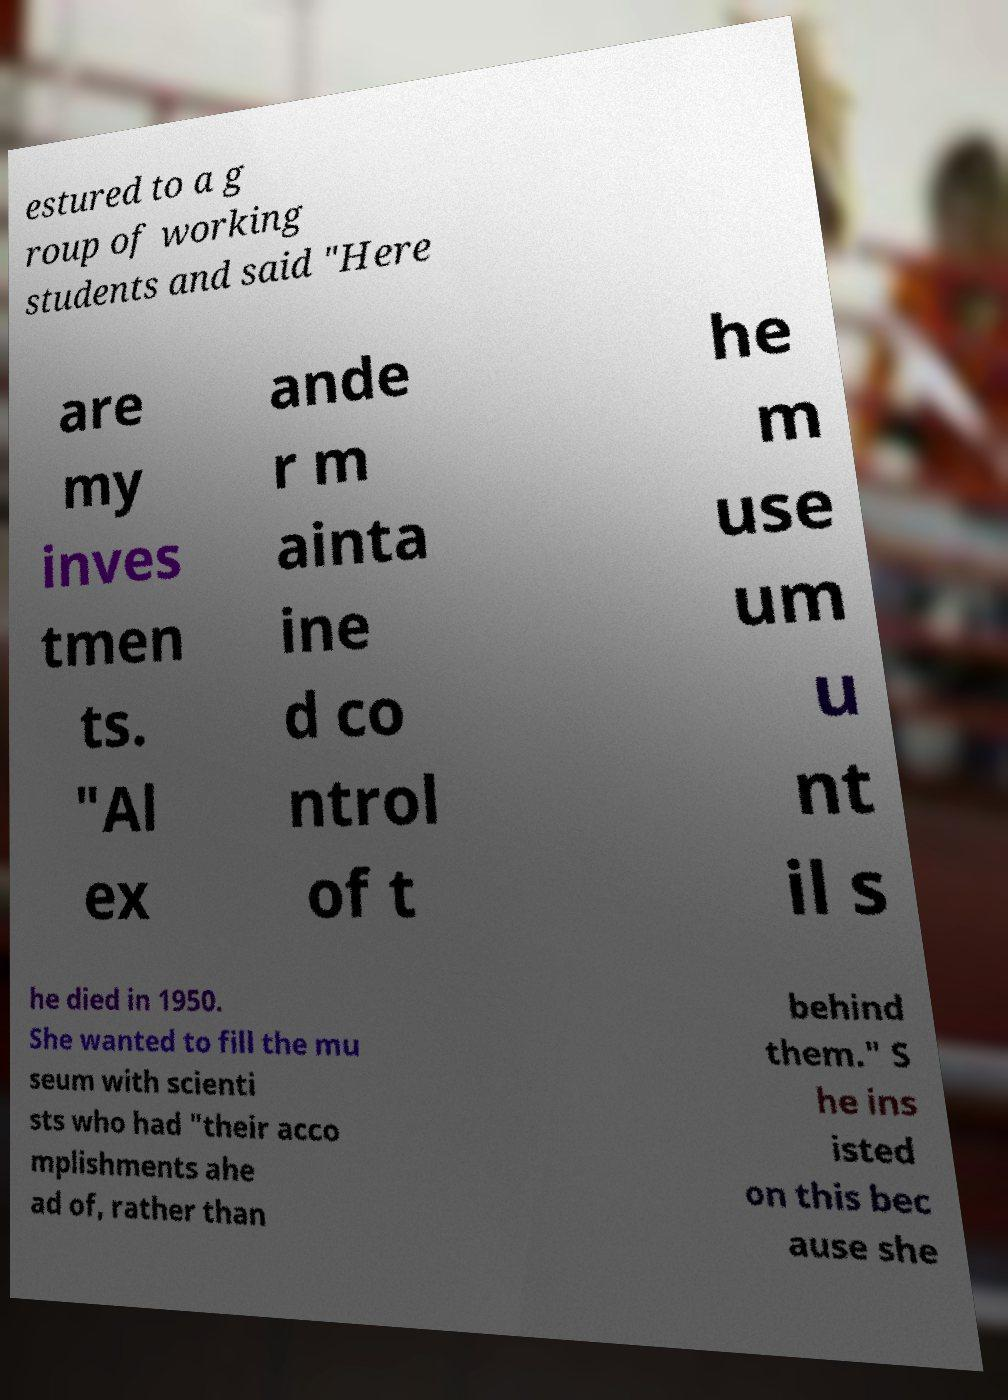Could you assist in decoding the text presented in this image and type it out clearly? estured to a g roup of working students and said "Here are my inves tmen ts. "Al ex ande r m ainta ine d co ntrol of t he m use um u nt il s he died in 1950. She wanted to fill the mu seum with scienti sts who had "their acco mplishments ahe ad of, rather than behind them." S he ins isted on this bec ause she 